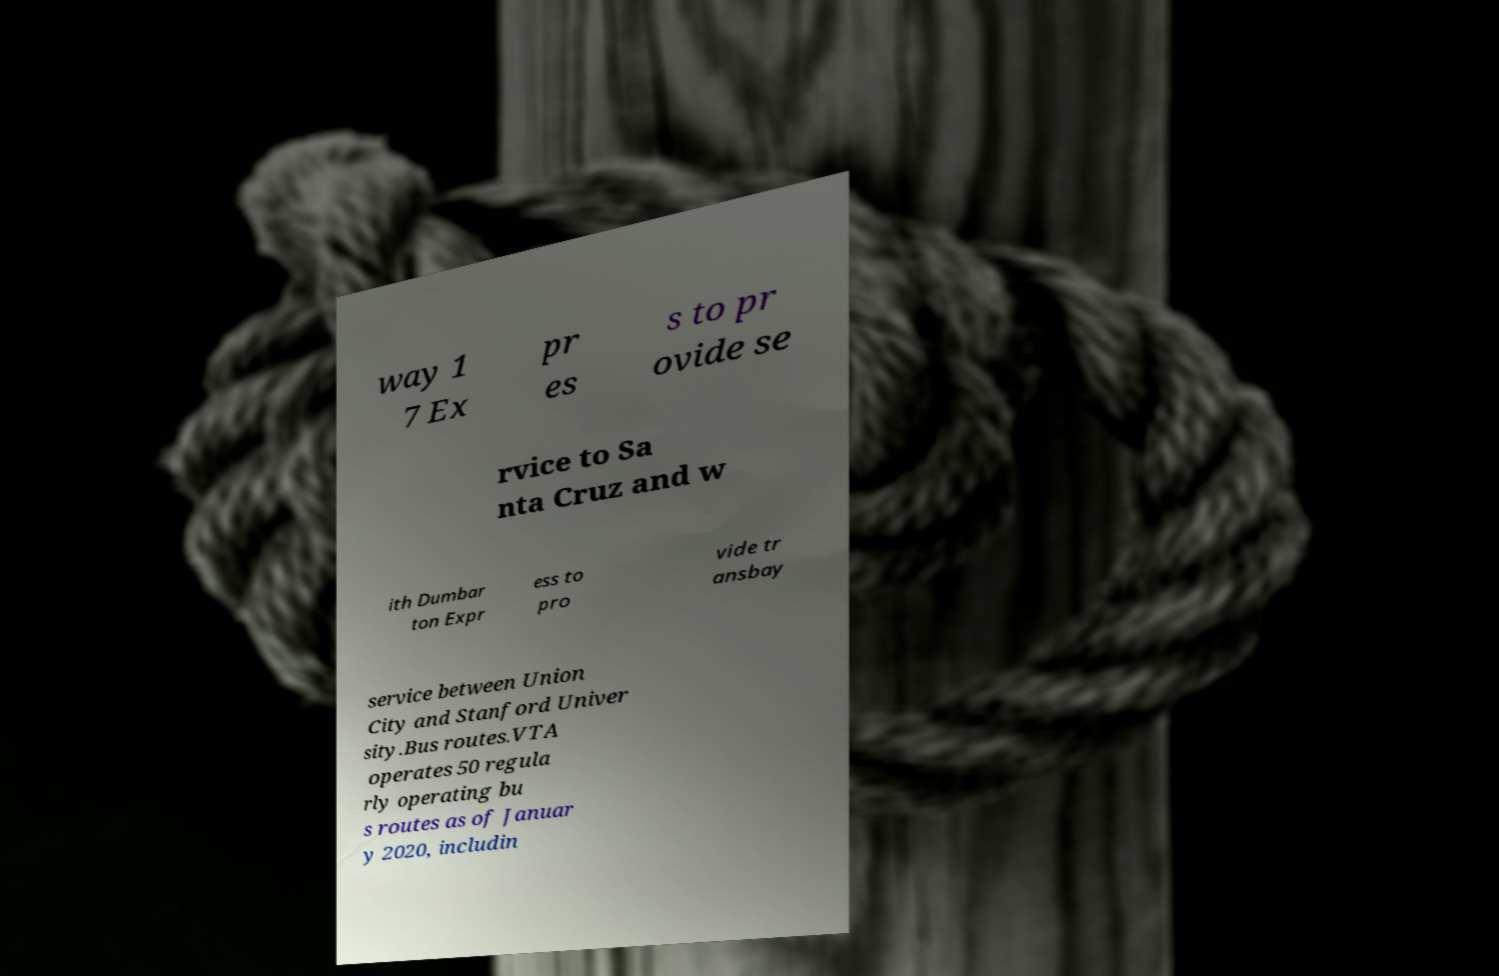Can you read and provide the text displayed in the image?This photo seems to have some interesting text. Can you extract and type it out for me? way 1 7 Ex pr es s to pr ovide se rvice to Sa nta Cruz and w ith Dumbar ton Expr ess to pro vide tr ansbay service between Union City and Stanford Univer sity.Bus routes.VTA operates 50 regula rly operating bu s routes as of Januar y 2020, includin 